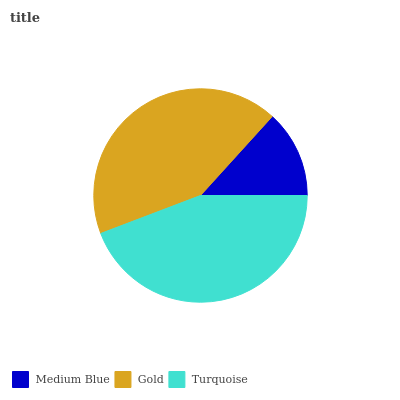Is Medium Blue the minimum?
Answer yes or no. Yes. Is Turquoise the maximum?
Answer yes or no. Yes. Is Gold the minimum?
Answer yes or no. No. Is Gold the maximum?
Answer yes or no. No. Is Gold greater than Medium Blue?
Answer yes or no. Yes. Is Medium Blue less than Gold?
Answer yes or no. Yes. Is Medium Blue greater than Gold?
Answer yes or no. No. Is Gold less than Medium Blue?
Answer yes or no. No. Is Gold the high median?
Answer yes or no. Yes. Is Gold the low median?
Answer yes or no. Yes. Is Turquoise the high median?
Answer yes or no. No. Is Medium Blue the low median?
Answer yes or no. No. 